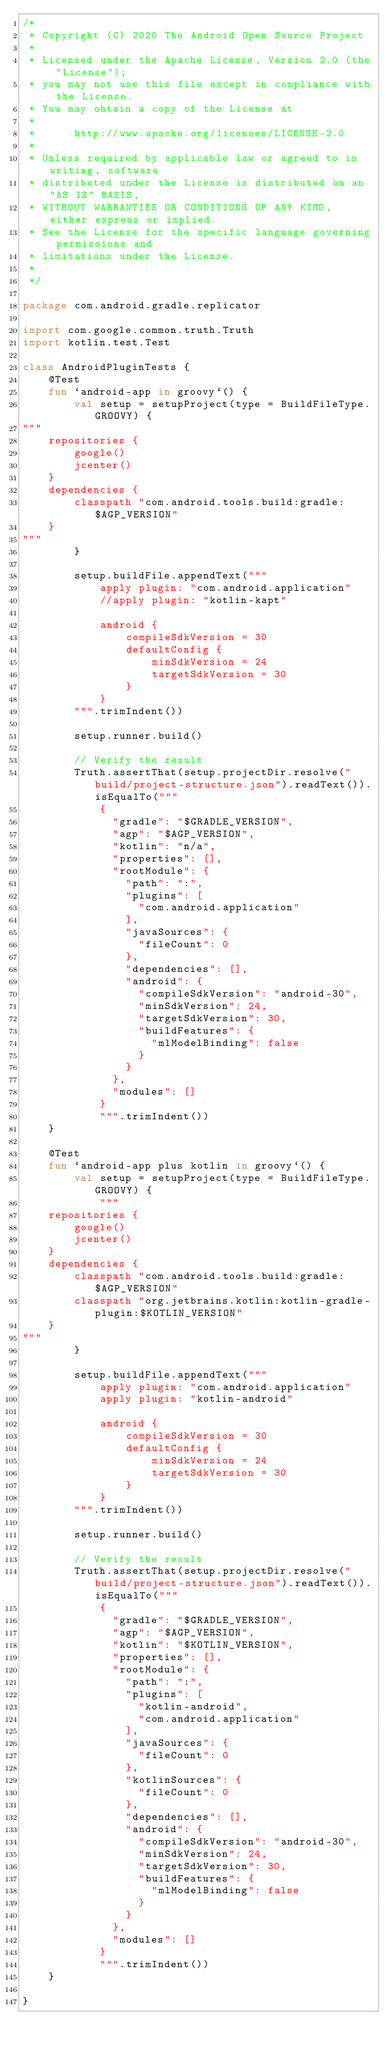Convert code to text. <code><loc_0><loc_0><loc_500><loc_500><_Kotlin_>/*
 * Copyright (C) 2020 The Android Open Source Project
 *
 * Licensed under the Apache License, Version 2.0 (the "License");
 * you may not use this file except in compliance with the License.
 * You may obtain a copy of the License at
 *
 *      http://www.apache.org/licenses/LICENSE-2.0
 *
 * Unless required by applicable law or agreed to in writing, software
 * distributed under the License is distributed on an "AS IS" BASIS,
 * WITHOUT WARRANTIES OR CONDITIONS OF ANY KIND, either express or implied.
 * See the License for the specific language governing permissions and
 * limitations under the License.
 *
 */

package com.android.gradle.replicator

import com.google.common.truth.Truth
import kotlin.test.Test

class AndroidPluginTests {
    @Test
    fun `android-app in groovy`() {
        val setup = setupProject(type = BuildFileType.GROOVY) {
"""
    repositories {
        google()
        jcenter()
    }
    dependencies {
        classpath "com.android.tools.build:gradle:$AGP_VERSION"
    }
"""
        }

        setup.buildFile.appendText("""
            apply plugin: "com.android.application"
            //apply plugin: "kotlin-kapt"
            
            android {
                compileSdkVersion = 30
                defaultConfig {
                    minSdkVersion = 24
                    targetSdkVersion = 30
                }
            }
        """.trimIndent())

        setup.runner.build()

        // Verify the result
        Truth.assertThat(setup.projectDir.resolve("build/project-structure.json").readText()).isEqualTo("""
            {
              "gradle": "$GRADLE_VERSION",
              "agp": "$AGP_VERSION",
              "kotlin": "n/a",
              "properties": [],
              "rootModule": {
                "path": ":",
                "plugins": [
                  "com.android.application"
                ],
                "javaSources": {
                  "fileCount": 0
                },
                "dependencies": [],
                "android": {
                  "compileSdkVersion": "android-30",
                  "minSdkVersion": 24,
                  "targetSdkVersion": 30,
                  "buildFeatures": {
                    "mlModelBinding": false
                  }
                }
              },
              "modules": []
            }
            """.trimIndent())
    }

    @Test
    fun `android-app plus kotlin in groovy`() {
        val setup = setupProject(type = BuildFileType.GROOVY) {
            """
    repositories {
        google()
        jcenter()
    }
    dependencies {
        classpath "com.android.tools.build:gradle:$AGP_VERSION"
        classpath "org.jetbrains.kotlin:kotlin-gradle-plugin:$KOTLIN_VERSION"
    }
"""
        }

        setup.buildFile.appendText("""
            apply plugin: "com.android.application"
            apply plugin: "kotlin-android"
            
            android {
                compileSdkVersion = 30            
                defaultConfig {
                    minSdkVersion = 24
                    targetSdkVersion = 30
                }
            }
        """.trimIndent())

        setup.runner.build()

        // Verify the result
        Truth.assertThat(setup.projectDir.resolve("build/project-structure.json").readText()).isEqualTo("""
            {
              "gradle": "$GRADLE_VERSION",
              "agp": "$AGP_VERSION",
              "kotlin": "$KOTLIN_VERSION",
              "properties": [],
              "rootModule": {
                "path": ":",
                "plugins": [
                  "kotlin-android",
                  "com.android.application"
                ],
                "javaSources": {
                  "fileCount": 0
                },
                "kotlinSources": {
                  "fileCount": 0
                },
                "dependencies": [],
                "android": {
                  "compileSdkVersion": "android-30",
                  "minSdkVersion": 24,
                  "targetSdkVersion": 30,
                  "buildFeatures": {
                    "mlModelBinding": false
                  }
                }
              },
              "modules": []
            }
            """.trimIndent())
    }

}</code> 